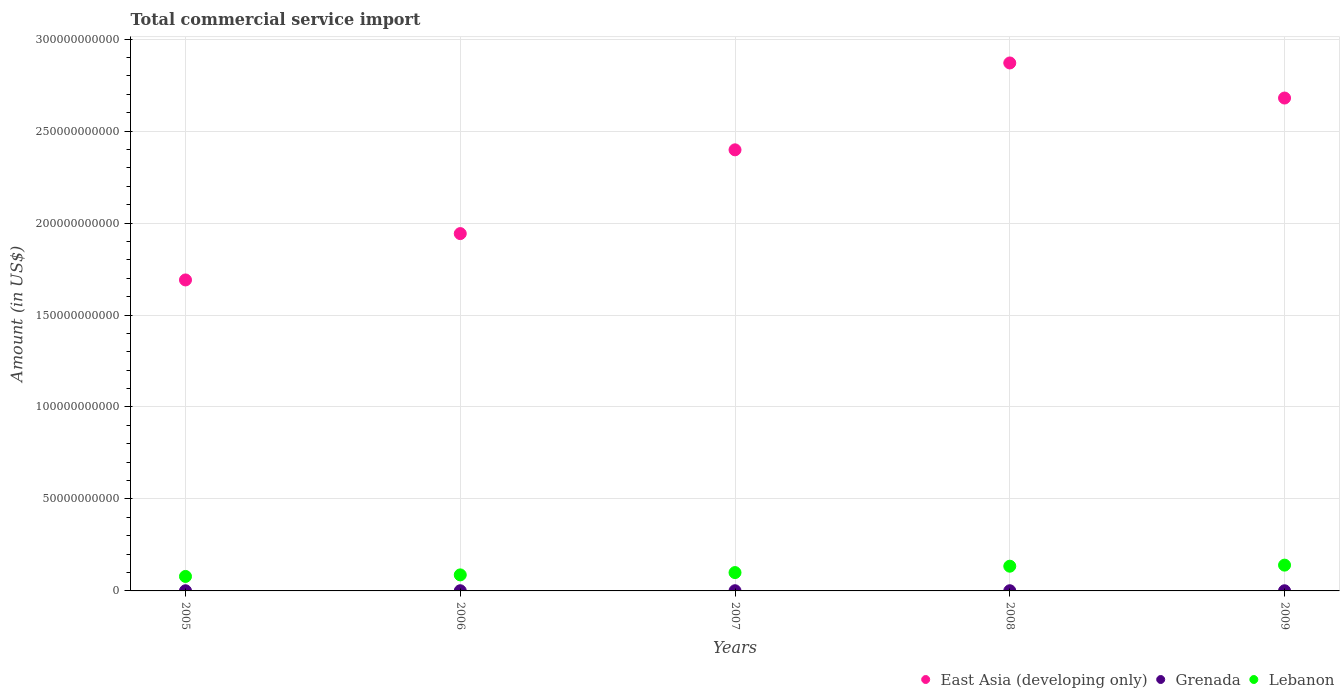How many different coloured dotlines are there?
Your answer should be compact. 3. Is the number of dotlines equal to the number of legend labels?
Your answer should be compact. Yes. What is the total commercial service import in Grenada in 2008?
Your response must be concise. 1.06e+08. Across all years, what is the maximum total commercial service import in Grenada?
Provide a succinct answer. 1.06e+08. Across all years, what is the minimum total commercial service import in Grenada?
Your response must be concise. 8.84e+07. What is the total total commercial service import in Lebanon in the graph?
Your answer should be compact. 5.40e+1. What is the difference between the total commercial service import in East Asia (developing only) in 2006 and that in 2007?
Provide a succinct answer. -4.55e+1. What is the difference between the total commercial service import in Lebanon in 2006 and the total commercial service import in East Asia (developing only) in 2007?
Give a very brief answer. -2.31e+11. What is the average total commercial service import in Lebanon per year?
Provide a succinct answer. 1.08e+1. In the year 2007, what is the difference between the total commercial service import in Grenada and total commercial service import in Lebanon?
Offer a very short reply. -9.86e+09. What is the ratio of the total commercial service import in Lebanon in 2007 to that in 2008?
Offer a very short reply. 0.74. Is the total commercial service import in Grenada in 2006 less than that in 2008?
Ensure brevity in your answer.  Yes. What is the difference between the highest and the second highest total commercial service import in East Asia (developing only)?
Give a very brief answer. 1.91e+1. What is the difference between the highest and the lowest total commercial service import in East Asia (developing only)?
Make the answer very short. 1.18e+11. Is it the case that in every year, the sum of the total commercial service import in East Asia (developing only) and total commercial service import in Lebanon  is greater than the total commercial service import in Grenada?
Your response must be concise. Yes. Is the total commercial service import in East Asia (developing only) strictly less than the total commercial service import in Lebanon over the years?
Offer a very short reply. No. How many dotlines are there?
Provide a short and direct response. 3. How many years are there in the graph?
Make the answer very short. 5. What is the difference between two consecutive major ticks on the Y-axis?
Ensure brevity in your answer.  5.00e+1. Are the values on the major ticks of Y-axis written in scientific E-notation?
Provide a succinct answer. No. Does the graph contain any zero values?
Offer a terse response. No. Does the graph contain grids?
Give a very brief answer. Yes. How many legend labels are there?
Offer a terse response. 3. What is the title of the graph?
Keep it short and to the point. Total commercial service import. Does "Bulgaria" appear as one of the legend labels in the graph?
Your answer should be very brief. No. What is the Amount (in US$) in East Asia (developing only) in 2005?
Offer a terse response. 1.69e+11. What is the Amount (in US$) in Grenada in 2005?
Your response must be concise. 8.84e+07. What is the Amount (in US$) of Lebanon in 2005?
Give a very brief answer. 7.87e+09. What is the Amount (in US$) of East Asia (developing only) in 2006?
Offer a very short reply. 1.94e+11. What is the Amount (in US$) of Grenada in 2006?
Your answer should be very brief. 1.01e+08. What is the Amount (in US$) of Lebanon in 2006?
Offer a terse response. 8.72e+09. What is the Amount (in US$) in East Asia (developing only) in 2007?
Your response must be concise. 2.40e+11. What is the Amount (in US$) in Grenada in 2007?
Make the answer very short. 1.04e+08. What is the Amount (in US$) of Lebanon in 2007?
Your answer should be very brief. 9.97e+09. What is the Amount (in US$) in East Asia (developing only) in 2008?
Make the answer very short. 2.87e+11. What is the Amount (in US$) in Grenada in 2008?
Offer a terse response. 1.06e+08. What is the Amount (in US$) in Lebanon in 2008?
Your answer should be compact. 1.34e+1. What is the Amount (in US$) in East Asia (developing only) in 2009?
Provide a succinct answer. 2.68e+11. What is the Amount (in US$) of Grenada in 2009?
Offer a very short reply. 9.14e+07. What is the Amount (in US$) in Lebanon in 2009?
Make the answer very short. 1.40e+1. Across all years, what is the maximum Amount (in US$) in East Asia (developing only)?
Keep it short and to the point. 2.87e+11. Across all years, what is the maximum Amount (in US$) in Grenada?
Your response must be concise. 1.06e+08. Across all years, what is the maximum Amount (in US$) of Lebanon?
Keep it short and to the point. 1.40e+1. Across all years, what is the minimum Amount (in US$) of East Asia (developing only)?
Offer a terse response. 1.69e+11. Across all years, what is the minimum Amount (in US$) of Grenada?
Your answer should be compact. 8.84e+07. Across all years, what is the minimum Amount (in US$) of Lebanon?
Your response must be concise. 7.87e+09. What is the total Amount (in US$) of East Asia (developing only) in the graph?
Your response must be concise. 1.16e+12. What is the total Amount (in US$) of Grenada in the graph?
Offer a very short reply. 4.91e+08. What is the total Amount (in US$) of Lebanon in the graph?
Offer a terse response. 5.40e+1. What is the difference between the Amount (in US$) of East Asia (developing only) in 2005 and that in 2006?
Your response must be concise. -2.52e+1. What is the difference between the Amount (in US$) of Grenada in 2005 and that in 2006?
Offer a very short reply. -1.27e+07. What is the difference between the Amount (in US$) of Lebanon in 2005 and that in 2006?
Keep it short and to the point. -8.41e+08. What is the difference between the Amount (in US$) in East Asia (developing only) in 2005 and that in 2007?
Ensure brevity in your answer.  -7.07e+1. What is the difference between the Amount (in US$) of Grenada in 2005 and that in 2007?
Your answer should be very brief. -1.60e+07. What is the difference between the Amount (in US$) of Lebanon in 2005 and that in 2007?
Your answer should be very brief. -2.09e+09. What is the difference between the Amount (in US$) of East Asia (developing only) in 2005 and that in 2008?
Keep it short and to the point. -1.18e+11. What is the difference between the Amount (in US$) in Grenada in 2005 and that in 2008?
Keep it short and to the point. -1.74e+07. What is the difference between the Amount (in US$) of Lebanon in 2005 and that in 2008?
Offer a terse response. -5.57e+09. What is the difference between the Amount (in US$) in East Asia (developing only) in 2005 and that in 2009?
Your response must be concise. -9.89e+1. What is the difference between the Amount (in US$) of Grenada in 2005 and that in 2009?
Make the answer very short. -2.99e+06. What is the difference between the Amount (in US$) in Lebanon in 2005 and that in 2009?
Ensure brevity in your answer.  -6.15e+09. What is the difference between the Amount (in US$) of East Asia (developing only) in 2006 and that in 2007?
Make the answer very short. -4.55e+1. What is the difference between the Amount (in US$) in Grenada in 2006 and that in 2007?
Your response must be concise. -3.28e+06. What is the difference between the Amount (in US$) of Lebanon in 2006 and that in 2007?
Keep it short and to the point. -1.25e+09. What is the difference between the Amount (in US$) in East Asia (developing only) in 2006 and that in 2008?
Give a very brief answer. -9.28e+1. What is the difference between the Amount (in US$) in Grenada in 2006 and that in 2008?
Your answer should be very brief. -4.69e+06. What is the difference between the Amount (in US$) of Lebanon in 2006 and that in 2008?
Keep it short and to the point. -4.72e+09. What is the difference between the Amount (in US$) in East Asia (developing only) in 2006 and that in 2009?
Your response must be concise. -7.37e+1. What is the difference between the Amount (in US$) of Grenada in 2006 and that in 2009?
Your answer should be very brief. 9.69e+06. What is the difference between the Amount (in US$) in Lebanon in 2006 and that in 2009?
Offer a terse response. -5.31e+09. What is the difference between the Amount (in US$) of East Asia (developing only) in 2007 and that in 2008?
Provide a succinct answer. -4.72e+1. What is the difference between the Amount (in US$) of Grenada in 2007 and that in 2008?
Ensure brevity in your answer.  -1.42e+06. What is the difference between the Amount (in US$) of Lebanon in 2007 and that in 2008?
Your answer should be very brief. -3.47e+09. What is the difference between the Amount (in US$) in East Asia (developing only) in 2007 and that in 2009?
Keep it short and to the point. -2.82e+1. What is the difference between the Amount (in US$) in Grenada in 2007 and that in 2009?
Provide a short and direct response. 1.30e+07. What is the difference between the Amount (in US$) in Lebanon in 2007 and that in 2009?
Your answer should be very brief. -4.06e+09. What is the difference between the Amount (in US$) of East Asia (developing only) in 2008 and that in 2009?
Keep it short and to the point. 1.91e+1. What is the difference between the Amount (in US$) of Grenada in 2008 and that in 2009?
Keep it short and to the point. 1.44e+07. What is the difference between the Amount (in US$) of Lebanon in 2008 and that in 2009?
Provide a short and direct response. -5.83e+08. What is the difference between the Amount (in US$) in East Asia (developing only) in 2005 and the Amount (in US$) in Grenada in 2006?
Offer a terse response. 1.69e+11. What is the difference between the Amount (in US$) in East Asia (developing only) in 2005 and the Amount (in US$) in Lebanon in 2006?
Ensure brevity in your answer.  1.60e+11. What is the difference between the Amount (in US$) of Grenada in 2005 and the Amount (in US$) of Lebanon in 2006?
Offer a terse response. -8.63e+09. What is the difference between the Amount (in US$) in East Asia (developing only) in 2005 and the Amount (in US$) in Grenada in 2007?
Keep it short and to the point. 1.69e+11. What is the difference between the Amount (in US$) of East Asia (developing only) in 2005 and the Amount (in US$) of Lebanon in 2007?
Offer a very short reply. 1.59e+11. What is the difference between the Amount (in US$) of Grenada in 2005 and the Amount (in US$) of Lebanon in 2007?
Your response must be concise. -9.88e+09. What is the difference between the Amount (in US$) in East Asia (developing only) in 2005 and the Amount (in US$) in Grenada in 2008?
Your answer should be compact. 1.69e+11. What is the difference between the Amount (in US$) of East Asia (developing only) in 2005 and the Amount (in US$) of Lebanon in 2008?
Offer a very short reply. 1.56e+11. What is the difference between the Amount (in US$) of Grenada in 2005 and the Amount (in US$) of Lebanon in 2008?
Your response must be concise. -1.34e+1. What is the difference between the Amount (in US$) of East Asia (developing only) in 2005 and the Amount (in US$) of Grenada in 2009?
Keep it short and to the point. 1.69e+11. What is the difference between the Amount (in US$) in East Asia (developing only) in 2005 and the Amount (in US$) in Lebanon in 2009?
Ensure brevity in your answer.  1.55e+11. What is the difference between the Amount (in US$) of Grenada in 2005 and the Amount (in US$) of Lebanon in 2009?
Offer a very short reply. -1.39e+1. What is the difference between the Amount (in US$) in East Asia (developing only) in 2006 and the Amount (in US$) in Grenada in 2007?
Ensure brevity in your answer.  1.94e+11. What is the difference between the Amount (in US$) in East Asia (developing only) in 2006 and the Amount (in US$) in Lebanon in 2007?
Provide a short and direct response. 1.84e+11. What is the difference between the Amount (in US$) of Grenada in 2006 and the Amount (in US$) of Lebanon in 2007?
Give a very brief answer. -9.87e+09. What is the difference between the Amount (in US$) of East Asia (developing only) in 2006 and the Amount (in US$) of Grenada in 2008?
Provide a short and direct response. 1.94e+11. What is the difference between the Amount (in US$) of East Asia (developing only) in 2006 and the Amount (in US$) of Lebanon in 2008?
Offer a terse response. 1.81e+11. What is the difference between the Amount (in US$) in Grenada in 2006 and the Amount (in US$) in Lebanon in 2008?
Keep it short and to the point. -1.33e+1. What is the difference between the Amount (in US$) of East Asia (developing only) in 2006 and the Amount (in US$) of Grenada in 2009?
Give a very brief answer. 1.94e+11. What is the difference between the Amount (in US$) of East Asia (developing only) in 2006 and the Amount (in US$) of Lebanon in 2009?
Offer a very short reply. 1.80e+11. What is the difference between the Amount (in US$) in Grenada in 2006 and the Amount (in US$) in Lebanon in 2009?
Make the answer very short. -1.39e+1. What is the difference between the Amount (in US$) of East Asia (developing only) in 2007 and the Amount (in US$) of Grenada in 2008?
Your answer should be very brief. 2.40e+11. What is the difference between the Amount (in US$) in East Asia (developing only) in 2007 and the Amount (in US$) in Lebanon in 2008?
Offer a terse response. 2.26e+11. What is the difference between the Amount (in US$) in Grenada in 2007 and the Amount (in US$) in Lebanon in 2008?
Make the answer very short. -1.33e+1. What is the difference between the Amount (in US$) in East Asia (developing only) in 2007 and the Amount (in US$) in Grenada in 2009?
Give a very brief answer. 2.40e+11. What is the difference between the Amount (in US$) of East Asia (developing only) in 2007 and the Amount (in US$) of Lebanon in 2009?
Offer a terse response. 2.26e+11. What is the difference between the Amount (in US$) in Grenada in 2007 and the Amount (in US$) in Lebanon in 2009?
Keep it short and to the point. -1.39e+1. What is the difference between the Amount (in US$) in East Asia (developing only) in 2008 and the Amount (in US$) in Grenada in 2009?
Your answer should be compact. 2.87e+11. What is the difference between the Amount (in US$) of East Asia (developing only) in 2008 and the Amount (in US$) of Lebanon in 2009?
Give a very brief answer. 2.73e+11. What is the difference between the Amount (in US$) of Grenada in 2008 and the Amount (in US$) of Lebanon in 2009?
Your answer should be compact. -1.39e+1. What is the average Amount (in US$) in East Asia (developing only) per year?
Provide a succinct answer. 2.32e+11. What is the average Amount (in US$) in Grenada per year?
Offer a terse response. 9.82e+07. What is the average Amount (in US$) in Lebanon per year?
Your answer should be very brief. 1.08e+1. In the year 2005, what is the difference between the Amount (in US$) of East Asia (developing only) and Amount (in US$) of Grenada?
Your answer should be very brief. 1.69e+11. In the year 2005, what is the difference between the Amount (in US$) in East Asia (developing only) and Amount (in US$) in Lebanon?
Provide a short and direct response. 1.61e+11. In the year 2005, what is the difference between the Amount (in US$) of Grenada and Amount (in US$) of Lebanon?
Offer a terse response. -7.79e+09. In the year 2006, what is the difference between the Amount (in US$) of East Asia (developing only) and Amount (in US$) of Grenada?
Keep it short and to the point. 1.94e+11. In the year 2006, what is the difference between the Amount (in US$) in East Asia (developing only) and Amount (in US$) in Lebanon?
Give a very brief answer. 1.86e+11. In the year 2006, what is the difference between the Amount (in US$) in Grenada and Amount (in US$) in Lebanon?
Your answer should be very brief. -8.61e+09. In the year 2007, what is the difference between the Amount (in US$) of East Asia (developing only) and Amount (in US$) of Grenada?
Offer a terse response. 2.40e+11. In the year 2007, what is the difference between the Amount (in US$) in East Asia (developing only) and Amount (in US$) in Lebanon?
Offer a very short reply. 2.30e+11. In the year 2007, what is the difference between the Amount (in US$) of Grenada and Amount (in US$) of Lebanon?
Give a very brief answer. -9.86e+09. In the year 2008, what is the difference between the Amount (in US$) in East Asia (developing only) and Amount (in US$) in Grenada?
Give a very brief answer. 2.87e+11. In the year 2008, what is the difference between the Amount (in US$) of East Asia (developing only) and Amount (in US$) of Lebanon?
Ensure brevity in your answer.  2.74e+11. In the year 2008, what is the difference between the Amount (in US$) of Grenada and Amount (in US$) of Lebanon?
Offer a terse response. -1.33e+1. In the year 2009, what is the difference between the Amount (in US$) in East Asia (developing only) and Amount (in US$) in Grenada?
Make the answer very short. 2.68e+11. In the year 2009, what is the difference between the Amount (in US$) in East Asia (developing only) and Amount (in US$) in Lebanon?
Offer a very short reply. 2.54e+11. In the year 2009, what is the difference between the Amount (in US$) of Grenada and Amount (in US$) of Lebanon?
Offer a very short reply. -1.39e+1. What is the ratio of the Amount (in US$) of East Asia (developing only) in 2005 to that in 2006?
Offer a terse response. 0.87. What is the ratio of the Amount (in US$) in Grenada in 2005 to that in 2006?
Offer a very short reply. 0.87. What is the ratio of the Amount (in US$) of Lebanon in 2005 to that in 2006?
Make the answer very short. 0.9. What is the ratio of the Amount (in US$) of East Asia (developing only) in 2005 to that in 2007?
Ensure brevity in your answer.  0.7. What is the ratio of the Amount (in US$) in Grenada in 2005 to that in 2007?
Provide a succinct answer. 0.85. What is the ratio of the Amount (in US$) of Lebanon in 2005 to that in 2007?
Provide a short and direct response. 0.79. What is the ratio of the Amount (in US$) of East Asia (developing only) in 2005 to that in 2008?
Give a very brief answer. 0.59. What is the ratio of the Amount (in US$) of Grenada in 2005 to that in 2008?
Your answer should be compact. 0.84. What is the ratio of the Amount (in US$) in Lebanon in 2005 to that in 2008?
Offer a terse response. 0.59. What is the ratio of the Amount (in US$) of East Asia (developing only) in 2005 to that in 2009?
Your response must be concise. 0.63. What is the ratio of the Amount (in US$) in Grenada in 2005 to that in 2009?
Offer a very short reply. 0.97. What is the ratio of the Amount (in US$) of Lebanon in 2005 to that in 2009?
Offer a very short reply. 0.56. What is the ratio of the Amount (in US$) in East Asia (developing only) in 2006 to that in 2007?
Your answer should be very brief. 0.81. What is the ratio of the Amount (in US$) of Grenada in 2006 to that in 2007?
Make the answer very short. 0.97. What is the ratio of the Amount (in US$) of Lebanon in 2006 to that in 2007?
Your answer should be very brief. 0.87. What is the ratio of the Amount (in US$) of East Asia (developing only) in 2006 to that in 2008?
Provide a succinct answer. 0.68. What is the ratio of the Amount (in US$) in Grenada in 2006 to that in 2008?
Your answer should be compact. 0.96. What is the ratio of the Amount (in US$) of Lebanon in 2006 to that in 2008?
Give a very brief answer. 0.65. What is the ratio of the Amount (in US$) of East Asia (developing only) in 2006 to that in 2009?
Offer a terse response. 0.72. What is the ratio of the Amount (in US$) in Grenada in 2006 to that in 2009?
Provide a short and direct response. 1.11. What is the ratio of the Amount (in US$) of Lebanon in 2006 to that in 2009?
Your response must be concise. 0.62. What is the ratio of the Amount (in US$) of East Asia (developing only) in 2007 to that in 2008?
Your answer should be very brief. 0.84. What is the ratio of the Amount (in US$) of Grenada in 2007 to that in 2008?
Your response must be concise. 0.99. What is the ratio of the Amount (in US$) of Lebanon in 2007 to that in 2008?
Keep it short and to the point. 0.74. What is the ratio of the Amount (in US$) in East Asia (developing only) in 2007 to that in 2009?
Provide a short and direct response. 0.89. What is the ratio of the Amount (in US$) in Grenada in 2007 to that in 2009?
Keep it short and to the point. 1.14. What is the ratio of the Amount (in US$) in Lebanon in 2007 to that in 2009?
Give a very brief answer. 0.71. What is the ratio of the Amount (in US$) in East Asia (developing only) in 2008 to that in 2009?
Ensure brevity in your answer.  1.07. What is the ratio of the Amount (in US$) of Grenada in 2008 to that in 2009?
Offer a very short reply. 1.16. What is the ratio of the Amount (in US$) in Lebanon in 2008 to that in 2009?
Ensure brevity in your answer.  0.96. What is the difference between the highest and the second highest Amount (in US$) of East Asia (developing only)?
Offer a very short reply. 1.91e+1. What is the difference between the highest and the second highest Amount (in US$) of Grenada?
Offer a terse response. 1.42e+06. What is the difference between the highest and the second highest Amount (in US$) in Lebanon?
Provide a short and direct response. 5.83e+08. What is the difference between the highest and the lowest Amount (in US$) of East Asia (developing only)?
Ensure brevity in your answer.  1.18e+11. What is the difference between the highest and the lowest Amount (in US$) of Grenada?
Offer a very short reply. 1.74e+07. What is the difference between the highest and the lowest Amount (in US$) in Lebanon?
Keep it short and to the point. 6.15e+09. 